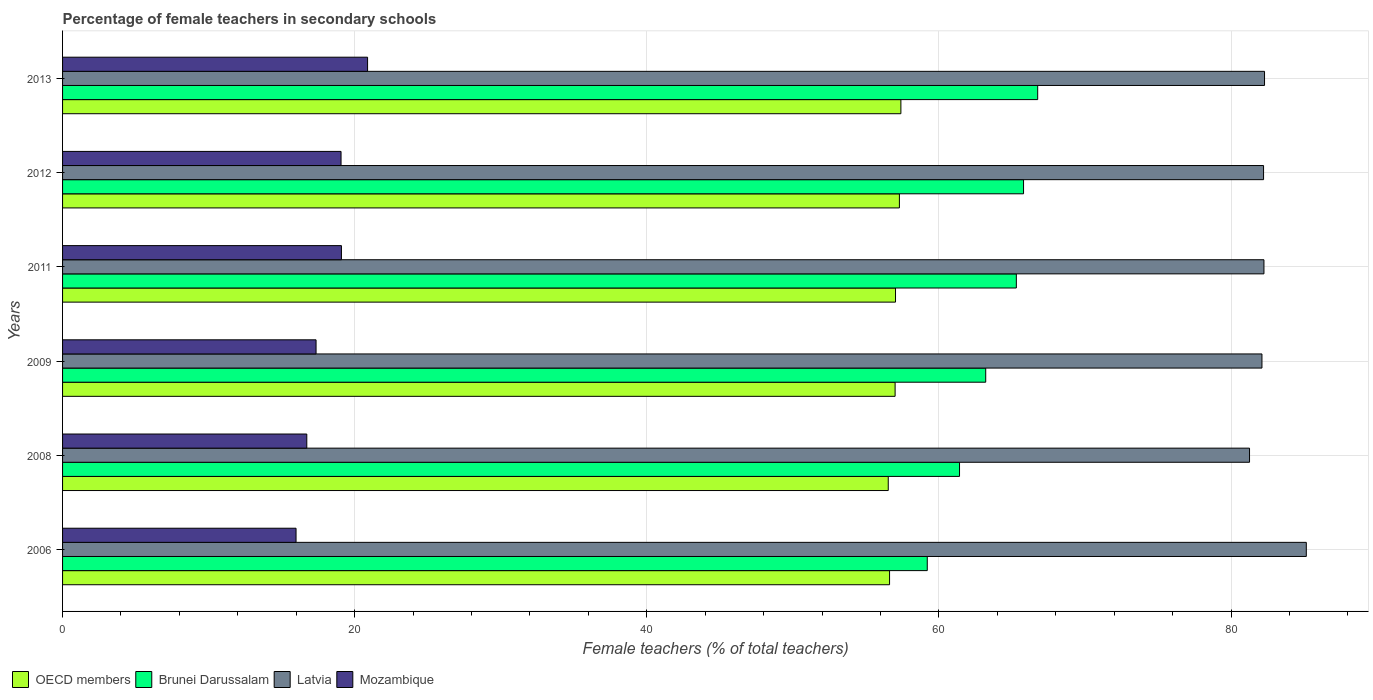How many groups of bars are there?
Provide a succinct answer. 6. Are the number of bars per tick equal to the number of legend labels?
Your response must be concise. Yes. How many bars are there on the 6th tick from the top?
Make the answer very short. 4. How many bars are there on the 2nd tick from the bottom?
Provide a succinct answer. 4. In how many cases, is the number of bars for a given year not equal to the number of legend labels?
Give a very brief answer. 0. What is the percentage of female teachers in Mozambique in 2009?
Ensure brevity in your answer.  17.36. Across all years, what is the maximum percentage of female teachers in Brunei Darussalam?
Make the answer very short. 66.76. Across all years, what is the minimum percentage of female teachers in OECD members?
Your answer should be very brief. 56.53. In which year was the percentage of female teachers in OECD members maximum?
Your answer should be compact. 2013. What is the total percentage of female teachers in Mozambique in the graph?
Ensure brevity in your answer.  109.1. What is the difference between the percentage of female teachers in Latvia in 2009 and that in 2013?
Offer a terse response. -0.18. What is the difference between the percentage of female teachers in Mozambique in 2013 and the percentage of female teachers in Latvia in 2012?
Your answer should be very brief. -61.34. What is the average percentage of female teachers in Mozambique per year?
Provide a short and direct response. 18.18. In the year 2012, what is the difference between the percentage of female teachers in Latvia and percentage of female teachers in OECD members?
Your answer should be very brief. 24.93. What is the ratio of the percentage of female teachers in OECD members in 2008 to that in 2011?
Your answer should be very brief. 0.99. Is the percentage of female teachers in Mozambique in 2011 less than that in 2013?
Your answer should be very brief. Yes. What is the difference between the highest and the second highest percentage of female teachers in Brunei Darussalam?
Offer a terse response. 0.97. What is the difference between the highest and the lowest percentage of female teachers in Mozambique?
Your response must be concise. 4.9. In how many years, is the percentage of female teachers in OECD members greater than the average percentage of female teachers in OECD members taken over all years?
Your response must be concise. 4. Is it the case that in every year, the sum of the percentage of female teachers in Latvia and percentage of female teachers in Brunei Darussalam is greater than the sum of percentage of female teachers in OECD members and percentage of female teachers in Mozambique?
Your response must be concise. Yes. What does the 3rd bar from the top in 2013 represents?
Your response must be concise. Brunei Darussalam. What does the 2nd bar from the bottom in 2006 represents?
Keep it short and to the point. Brunei Darussalam. Is it the case that in every year, the sum of the percentage of female teachers in Latvia and percentage of female teachers in OECD members is greater than the percentage of female teachers in Mozambique?
Provide a short and direct response. Yes. How many bars are there?
Provide a succinct answer. 24. Are all the bars in the graph horizontal?
Offer a very short reply. Yes. Does the graph contain any zero values?
Provide a short and direct response. No. How many legend labels are there?
Provide a succinct answer. 4. How are the legend labels stacked?
Make the answer very short. Horizontal. What is the title of the graph?
Your answer should be compact. Percentage of female teachers in secondary schools. Does "Mexico" appear as one of the legend labels in the graph?
Offer a very short reply. No. What is the label or title of the X-axis?
Keep it short and to the point. Female teachers (% of total teachers). What is the label or title of the Y-axis?
Ensure brevity in your answer.  Years. What is the Female teachers (% of total teachers) in OECD members in 2006?
Provide a succinct answer. 56.62. What is the Female teachers (% of total teachers) in Brunei Darussalam in 2006?
Your answer should be compact. 59.2. What is the Female teachers (% of total teachers) of Latvia in 2006?
Your answer should be very brief. 85.15. What is the Female teachers (% of total teachers) in Mozambique in 2006?
Make the answer very short. 15.99. What is the Female teachers (% of total teachers) in OECD members in 2008?
Give a very brief answer. 56.53. What is the Female teachers (% of total teachers) of Brunei Darussalam in 2008?
Offer a very short reply. 61.41. What is the Female teachers (% of total teachers) in Latvia in 2008?
Offer a very short reply. 81.27. What is the Female teachers (% of total teachers) of Mozambique in 2008?
Give a very brief answer. 16.72. What is the Female teachers (% of total teachers) in OECD members in 2009?
Your answer should be compact. 57. What is the Female teachers (% of total teachers) in Brunei Darussalam in 2009?
Make the answer very short. 63.2. What is the Female teachers (% of total teachers) in Latvia in 2009?
Provide a succinct answer. 82.12. What is the Female teachers (% of total teachers) in Mozambique in 2009?
Offer a terse response. 17.36. What is the Female teachers (% of total teachers) of OECD members in 2011?
Give a very brief answer. 57.03. What is the Female teachers (% of total teachers) in Brunei Darussalam in 2011?
Your answer should be very brief. 65.3. What is the Female teachers (% of total teachers) of Latvia in 2011?
Your answer should be compact. 82.25. What is the Female teachers (% of total teachers) in Mozambique in 2011?
Keep it short and to the point. 19.09. What is the Female teachers (% of total teachers) of OECD members in 2012?
Offer a very short reply. 57.29. What is the Female teachers (% of total teachers) of Brunei Darussalam in 2012?
Make the answer very short. 65.79. What is the Female teachers (% of total teachers) of Latvia in 2012?
Offer a terse response. 82.23. What is the Female teachers (% of total teachers) of Mozambique in 2012?
Offer a very short reply. 19.07. What is the Female teachers (% of total teachers) of OECD members in 2013?
Keep it short and to the point. 57.4. What is the Female teachers (% of total teachers) in Brunei Darussalam in 2013?
Provide a succinct answer. 66.76. What is the Female teachers (% of total teachers) of Latvia in 2013?
Provide a succinct answer. 82.29. What is the Female teachers (% of total teachers) of Mozambique in 2013?
Keep it short and to the point. 20.88. Across all years, what is the maximum Female teachers (% of total teachers) in OECD members?
Ensure brevity in your answer.  57.4. Across all years, what is the maximum Female teachers (% of total teachers) in Brunei Darussalam?
Your answer should be very brief. 66.76. Across all years, what is the maximum Female teachers (% of total teachers) in Latvia?
Provide a succinct answer. 85.15. Across all years, what is the maximum Female teachers (% of total teachers) in Mozambique?
Offer a terse response. 20.88. Across all years, what is the minimum Female teachers (% of total teachers) of OECD members?
Keep it short and to the point. 56.53. Across all years, what is the minimum Female teachers (% of total teachers) in Brunei Darussalam?
Your response must be concise. 59.2. Across all years, what is the minimum Female teachers (% of total teachers) in Latvia?
Your response must be concise. 81.27. Across all years, what is the minimum Female teachers (% of total teachers) in Mozambique?
Make the answer very short. 15.99. What is the total Female teachers (% of total teachers) in OECD members in the graph?
Offer a very short reply. 341.87. What is the total Female teachers (% of total teachers) of Brunei Darussalam in the graph?
Provide a succinct answer. 381.67. What is the total Female teachers (% of total teachers) of Latvia in the graph?
Your response must be concise. 495.3. What is the total Female teachers (% of total teachers) in Mozambique in the graph?
Ensure brevity in your answer.  109.1. What is the difference between the Female teachers (% of total teachers) of OECD members in 2006 and that in 2008?
Provide a succinct answer. 0.09. What is the difference between the Female teachers (% of total teachers) in Brunei Darussalam in 2006 and that in 2008?
Give a very brief answer. -2.21. What is the difference between the Female teachers (% of total teachers) in Latvia in 2006 and that in 2008?
Your answer should be very brief. 3.89. What is the difference between the Female teachers (% of total teachers) in Mozambique in 2006 and that in 2008?
Provide a succinct answer. -0.74. What is the difference between the Female teachers (% of total teachers) in OECD members in 2006 and that in 2009?
Give a very brief answer. -0.38. What is the difference between the Female teachers (% of total teachers) of Brunei Darussalam in 2006 and that in 2009?
Keep it short and to the point. -4. What is the difference between the Female teachers (% of total teachers) in Latvia in 2006 and that in 2009?
Offer a very short reply. 3.04. What is the difference between the Female teachers (% of total teachers) of Mozambique in 2006 and that in 2009?
Your answer should be very brief. -1.37. What is the difference between the Female teachers (% of total teachers) in OECD members in 2006 and that in 2011?
Your response must be concise. -0.41. What is the difference between the Female teachers (% of total teachers) of Brunei Darussalam in 2006 and that in 2011?
Provide a succinct answer. -6.1. What is the difference between the Female teachers (% of total teachers) in Latvia in 2006 and that in 2011?
Your response must be concise. 2.9. What is the difference between the Female teachers (% of total teachers) of Mozambique in 2006 and that in 2011?
Your answer should be very brief. -3.11. What is the difference between the Female teachers (% of total teachers) in OECD members in 2006 and that in 2012?
Your response must be concise. -0.67. What is the difference between the Female teachers (% of total teachers) of Brunei Darussalam in 2006 and that in 2012?
Your answer should be very brief. -6.59. What is the difference between the Female teachers (% of total teachers) of Latvia in 2006 and that in 2012?
Offer a terse response. 2.93. What is the difference between the Female teachers (% of total teachers) in Mozambique in 2006 and that in 2012?
Provide a short and direct response. -3.08. What is the difference between the Female teachers (% of total teachers) in OECD members in 2006 and that in 2013?
Your response must be concise. -0.78. What is the difference between the Female teachers (% of total teachers) of Brunei Darussalam in 2006 and that in 2013?
Offer a very short reply. -7.56. What is the difference between the Female teachers (% of total teachers) of Latvia in 2006 and that in 2013?
Provide a succinct answer. 2.86. What is the difference between the Female teachers (% of total teachers) of Mozambique in 2006 and that in 2013?
Ensure brevity in your answer.  -4.9. What is the difference between the Female teachers (% of total teachers) in OECD members in 2008 and that in 2009?
Your answer should be compact. -0.47. What is the difference between the Female teachers (% of total teachers) of Brunei Darussalam in 2008 and that in 2009?
Provide a short and direct response. -1.79. What is the difference between the Female teachers (% of total teachers) of Latvia in 2008 and that in 2009?
Provide a short and direct response. -0.85. What is the difference between the Female teachers (% of total teachers) in Mozambique in 2008 and that in 2009?
Your answer should be compact. -0.63. What is the difference between the Female teachers (% of total teachers) of OECD members in 2008 and that in 2011?
Your response must be concise. -0.5. What is the difference between the Female teachers (% of total teachers) of Brunei Darussalam in 2008 and that in 2011?
Offer a terse response. -3.89. What is the difference between the Female teachers (% of total teachers) of Latvia in 2008 and that in 2011?
Provide a succinct answer. -0.99. What is the difference between the Female teachers (% of total teachers) of Mozambique in 2008 and that in 2011?
Offer a terse response. -2.37. What is the difference between the Female teachers (% of total teachers) in OECD members in 2008 and that in 2012?
Provide a succinct answer. -0.76. What is the difference between the Female teachers (% of total teachers) of Brunei Darussalam in 2008 and that in 2012?
Your response must be concise. -4.38. What is the difference between the Female teachers (% of total teachers) of Latvia in 2008 and that in 2012?
Your answer should be compact. -0.96. What is the difference between the Female teachers (% of total teachers) of Mozambique in 2008 and that in 2012?
Ensure brevity in your answer.  -2.34. What is the difference between the Female teachers (% of total teachers) of OECD members in 2008 and that in 2013?
Your response must be concise. -0.87. What is the difference between the Female teachers (% of total teachers) in Brunei Darussalam in 2008 and that in 2013?
Your response must be concise. -5.35. What is the difference between the Female teachers (% of total teachers) of Latvia in 2008 and that in 2013?
Offer a terse response. -1.03. What is the difference between the Female teachers (% of total teachers) of Mozambique in 2008 and that in 2013?
Your answer should be compact. -4.16. What is the difference between the Female teachers (% of total teachers) of OECD members in 2009 and that in 2011?
Offer a very short reply. -0.03. What is the difference between the Female teachers (% of total teachers) in Brunei Darussalam in 2009 and that in 2011?
Keep it short and to the point. -2.1. What is the difference between the Female teachers (% of total teachers) in Latvia in 2009 and that in 2011?
Ensure brevity in your answer.  -0.14. What is the difference between the Female teachers (% of total teachers) of Mozambique in 2009 and that in 2011?
Provide a short and direct response. -1.74. What is the difference between the Female teachers (% of total teachers) in OECD members in 2009 and that in 2012?
Your answer should be very brief. -0.29. What is the difference between the Female teachers (% of total teachers) in Brunei Darussalam in 2009 and that in 2012?
Provide a succinct answer. -2.59. What is the difference between the Female teachers (% of total teachers) of Latvia in 2009 and that in 2012?
Provide a short and direct response. -0.11. What is the difference between the Female teachers (% of total teachers) in Mozambique in 2009 and that in 2012?
Give a very brief answer. -1.71. What is the difference between the Female teachers (% of total teachers) of OECD members in 2009 and that in 2013?
Provide a short and direct response. -0.4. What is the difference between the Female teachers (% of total teachers) in Brunei Darussalam in 2009 and that in 2013?
Provide a succinct answer. -3.56. What is the difference between the Female teachers (% of total teachers) of Latvia in 2009 and that in 2013?
Your answer should be very brief. -0.18. What is the difference between the Female teachers (% of total teachers) in Mozambique in 2009 and that in 2013?
Provide a succinct answer. -3.53. What is the difference between the Female teachers (% of total teachers) in OECD members in 2011 and that in 2012?
Provide a succinct answer. -0.27. What is the difference between the Female teachers (% of total teachers) of Brunei Darussalam in 2011 and that in 2012?
Offer a terse response. -0.49. What is the difference between the Female teachers (% of total teachers) in Latvia in 2011 and that in 2012?
Your answer should be compact. 0.03. What is the difference between the Female teachers (% of total teachers) of Mozambique in 2011 and that in 2012?
Provide a succinct answer. 0.03. What is the difference between the Female teachers (% of total teachers) in OECD members in 2011 and that in 2013?
Make the answer very short. -0.37. What is the difference between the Female teachers (% of total teachers) in Brunei Darussalam in 2011 and that in 2013?
Make the answer very short. -1.46. What is the difference between the Female teachers (% of total teachers) of Latvia in 2011 and that in 2013?
Offer a very short reply. -0.04. What is the difference between the Female teachers (% of total teachers) of Mozambique in 2011 and that in 2013?
Give a very brief answer. -1.79. What is the difference between the Female teachers (% of total teachers) in OECD members in 2012 and that in 2013?
Offer a terse response. -0.1. What is the difference between the Female teachers (% of total teachers) of Brunei Darussalam in 2012 and that in 2013?
Keep it short and to the point. -0.97. What is the difference between the Female teachers (% of total teachers) in Latvia in 2012 and that in 2013?
Keep it short and to the point. -0.07. What is the difference between the Female teachers (% of total teachers) in Mozambique in 2012 and that in 2013?
Provide a succinct answer. -1.82. What is the difference between the Female teachers (% of total teachers) of OECD members in 2006 and the Female teachers (% of total teachers) of Brunei Darussalam in 2008?
Offer a terse response. -4.79. What is the difference between the Female teachers (% of total teachers) of OECD members in 2006 and the Female teachers (% of total teachers) of Latvia in 2008?
Your answer should be compact. -24.65. What is the difference between the Female teachers (% of total teachers) of OECD members in 2006 and the Female teachers (% of total teachers) of Mozambique in 2008?
Keep it short and to the point. 39.9. What is the difference between the Female teachers (% of total teachers) of Brunei Darussalam in 2006 and the Female teachers (% of total teachers) of Latvia in 2008?
Keep it short and to the point. -22.06. What is the difference between the Female teachers (% of total teachers) in Brunei Darussalam in 2006 and the Female teachers (% of total teachers) in Mozambique in 2008?
Provide a succinct answer. 42.48. What is the difference between the Female teachers (% of total teachers) in Latvia in 2006 and the Female teachers (% of total teachers) in Mozambique in 2008?
Ensure brevity in your answer.  68.43. What is the difference between the Female teachers (% of total teachers) in OECD members in 2006 and the Female teachers (% of total teachers) in Brunei Darussalam in 2009?
Your response must be concise. -6.58. What is the difference between the Female teachers (% of total teachers) of OECD members in 2006 and the Female teachers (% of total teachers) of Latvia in 2009?
Provide a succinct answer. -25.5. What is the difference between the Female teachers (% of total teachers) of OECD members in 2006 and the Female teachers (% of total teachers) of Mozambique in 2009?
Offer a very short reply. 39.26. What is the difference between the Female teachers (% of total teachers) in Brunei Darussalam in 2006 and the Female teachers (% of total teachers) in Latvia in 2009?
Your answer should be very brief. -22.91. What is the difference between the Female teachers (% of total teachers) in Brunei Darussalam in 2006 and the Female teachers (% of total teachers) in Mozambique in 2009?
Provide a succinct answer. 41.85. What is the difference between the Female teachers (% of total teachers) of Latvia in 2006 and the Female teachers (% of total teachers) of Mozambique in 2009?
Offer a very short reply. 67.8. What is the difference between the Female teachers (% of total teachers) of OECD members in 2006 and the Female teachers (% of total teachers) of Brunei Darussalam in 2011?
Provide a short and direct response. -8.68. What is the difference between the Female teachers (% of total teachers) in OECD members in 2006 and the Female teachers (% of total teachers) in Latvia in 2011?
Provide a short and direct response. -25.63. What is the difference between the Female teachers (% of total teachers) of OECD members in 2006 and the Female teachers (% of total teachers) of Mozambique in 2011?
Provide a short and direct response. 37.53. What is the difference between the Female teachers (% of total teachers) in Brunei Darussalam in 2006 and the Female teachers (% of total teachers) in Latvia in 2011?
Offer a very short reply. -23.05. What is the difference between the Female teachers (% of total teachers) in Brunei Darussalam in 2006 and the Female teachers (% of total teachers) in Mozambique in 2011?
Your answer should be compact. 40.11. What is the difference between the Female teachers (% of total teachers) of Latvia in 2006 and the Female teachers (% of total teachers) of Mozambique in 2011?
Make the answer very short. 66.06. What is the difference between the Female teachers (% of total teachers) in OECD members in 2006 and the Female teachers (% of total teachers) in Brunei Darussalam in 2012?
Provide a short and direct response. -9.17. What is the difference between the Female teachers (% of total teachers) of OECD members in 2006 and the Female teachers (% of total teachers) of Latvia in 2012?
Give a very brief answer. -25.61. What is the difference between the Female teachers (% of total teachers) in OECD members in 2006 and the Female teachers (% of total teachers) in Mozambique in 2012?
Your response must be concise. 37.55. What is the difference between the Female teachers (% of total teachers) in Brunei Darussalam in 2006 and the Female teachers (% of total teachers) in Latvia in 2012?
Provide a succinct answer. -23.02. What is the difference between the Female teachers (% of total teachers) in Brunei Darussalam in 2006 and the Female teachers (% of total teachers) in Mozambique in 2012?
Offer a very short reply. 40.14. What is the difference between the Female teachers (% of total teachers) in Latvia in 2006 and the Female teachers (% of total teachers) in Mozambique in 2012?
Provide a short and direct response. 66.09. What is the difference between the Female teachers (% of total teachers) in OECD members in 2006 and the Female teachers (% of total teachers) in Brunei Darussalam in 2013?
Provide a short and direct response. -10.14. What is the difference between the Female teachers (% of total teachers) in OECD members in 2006 and the Female teachers (% of total teachers) in Latvia in 2013?
Provide a short and direct response. -25.67. What is the difference between the Female teachers (% of total teachers) in OECD members in 2006 and the Female teachers (% of total teachers) in Mozambique in 2013?
Offer a terse response. 35.74. What is the difference between the Female teachers (% of total teachers) in Brunei Darussalam in 2006 and the Female teachers (% of total teachers) in Latvia in 2013?
Ensure brevity in your answer.  -23.09. What is the difference between the Female teachers (% of total teachers) in Brunei Darussalam in 2006 and the Female teachers (% of total teachers) in Mozambique in 2013?
Your response must be concise. 38.32. What is the difference between the Female teachers (% of total teachers) of Latvia in 2006 and the Female teachers (% of total teachers) of Mozambique in 2013?
Your answer should be very brief. 64.27. What is the difference between the Female teachers (% of total teachers) in OECD members in 2008 and the Female teachers (% of total teachers) in Brunei Darussalam in 2009?
Offer a terse response. -6.67. What is the difference between the Female teachers (% of total teachers) in OECD members in 2008 and the Female teachers (% of total teachers) in Latvia in 2009?
Offer a terse response. -25.59. What is the difference between the Female teachers (% of total teachers) of OECD members in 2008 and the Female teachers (% of total teachers) of Mozambique in 2009?
Offer a terse response. 39.18. What is the difference between the Female teachers (% of total teachers) in Brunei Darussalam in 2008 and the Female teachers (% of total teachers) in Latvia in 2009?
Give a very brief answer. -20.71. What is the difference between the Female teachers (% of total teachers) of Brunei Darussalam in 2008 and the Female teachers (% of total teachers) of Mozambique in 2009?
Your response must be concise. 44.06. What is the difference between the Female teachers (% of total teachers) of Latvia in 2008 and the Female teachers (% of total teachers) of Mozambique in 2009?
Ensure brevity in your answer.  63.91. What is the difference between the Female teachers (% of total teachers) of OECD members in 2008 and the Female teachers (% of total teachers) of Brunei Darussalam in 2011?
Ensure brevity in your answer.  -8.77. What is the difference between the Female teachers (% of total teachers) in OECD members in 2008 and the Female teachers (% of total teachers) in Latvia in 2011?
Your answer should be compact. -25.72. What is the difference between the Female teachers (% of total teachers) in OECD members in 2008 and the Female teachers (% of total teachers) in Mozambique in 2011?
Offer a terse response. 37.44. What is the difference between the Female teachers (% of total teachers) of Brunei Darussalam in 2008 and the Female teachers (% of total teachers) of Latvia in 2011?
Make the answer very short. -20.84. What is the difference between the Female teachers (% of total teachers) in Brunei Darussalam in 2008 and the Female teachers (% of total teachers) in Mozambique in 2011?
Your response must be concise. 42.32. What is the difference between the Female teachers (% of total teachers) in Latvia in 2008 and the Female teachers (% of total teachers) in Mozambique in 2011?
Provide a short and direct response. 62.17. What is the difference between the Female teachers (% of total teachers) of OECD members in 2008 and the Female teachers (% of total teachers) of Brunei Darussalam in 2012?
Provide a succinct answer. -9.26. What is the difference between the Female teachers (% of total teachers) of OECD members in 2008 and the Female teachers (% of total teachers) of Latvia in 2012?
Provide a succinct answer. -25.7. What is the difference between the Female teachers (% of total teachers) of OECD members in 2008 and the Female teachers (% of total teachers) of Mozambique in 2012?
Provide a succinct answer. 37.46. What is the difference between the Female teachers (% of total teachers) in Brunei Darussalam in 2008 and the Female teachers (% of total teachers) in Latvia in 2012?
Make the answer very short. -20.82. What is the difference between the Female teachers (% of total teachers) of Brunei Darussalam in 2008 and the Female teachers (% of total teachers) of Mozambique in 2012?
Provide a short and direct response. 42.34. What is the difference between the Female teachers (% of total teachers) in Latvia in 2008 and the Female teachers (% of total teachers) in Mozambique in 2012?
Provide a short and direct response. 62.2. What is the difference between the Female teachers (% of total teachers) of OECD members in 2008 and the Female teachers (% of total teachers) of Brunei Darussalam in 2013?
Keep it short and to the point. -10.23. What is the difference between the Female teachers (% of total teachers) of OECD members in 2008 and the Female teachers (% of total teachers) of Latvia in 2013?
Your answer should be compact. -25.76. What is the difference between the Female teachers (% of total teachers) of OECD members in 2008 and the Female teachers (% of total teachers) of Mozambique in 2013?
Provide a succinct answer. 35.65. What is the difference between the Female teachers (% of total teachers) of Brunei Darussalam in 2008 and the Female teachers (% of total teachers) of Latvia in 2013?
Your answer should be very brief. -20.88. What is the difference between the Female teachers (% of total teachers) in Brunei Darussalam in 2008 and the Female teachers (% of total teachers) in Mozambique in 2013?
Offer a very short reply. 40.53. What is the difference between the Female teachers (% of total teachers) of Latvia in 2008 and the Female teachers (% of total teachers) of Mozambique in 2013?
Provide a succinct answer. 60.38. What is the difference between the Female teachers (% of total teachers) of OECD members in 2009 and the Female teachers (% of total teachers) of Brunei Darussalam in 2011?
Your answer should be very brief. -8.3. What is the difference between the Female teachers (% of total teachers) of OECD members in 2009 and the Female teachers (% of total teachers) of Latvia in 2011?
Provide a succinct answer. -25.25. What is the difference between the Female teachers (% of total teachers) in OECD members in 2009 and the Female teachers (% of total teachers) in Mozambique in 2011?
Your answer should be very brief. 37.91. What is the difference between the Female teachers (% of total teachers) of Brunei Darussalam in 2009 and the Female teachers (% of total teachers) of Latvia in 2011?
Keep it short and to the point. -19.05. What is the difference between the Female teachers (% of total teachers) of Brunei Darussalam in 2009 and the Female teachers (% of total teachers) of Mozambique in 2011?
Provide a short and direct response. 44.11. What is the difference between the Female teachers (% of total teachers) in Latvia in 2009 and the Female teachers (% of total teachers) in Mozambique in 2011?
Your answer should be very brief. 63.02. What is the difference between the Female teachers (% of total teachers) of OECD members in 2009 and the Female teachers (% of total teachers) of Brunei Darussalam in 2012?
Your answer should be compact. -8.79. What is the difference between the Female teachers (% of total teachers) in OECD members in 2009 and the Female teachers (% of total teachers) in Latvia in 2012?
Provide a succinct answer. -25.23. What is the difference between the Female teachers (% of total teachers) in OECD members in 2009 and the Female teachers (% of total teachers) in Mozambique in 2012?
Provide a succinct answer. 37.93. What is the difference between the Female teachers (% of total teachers) of Brunei Darussalam in 2009 and the Female teachers (% of total teachers) of Latvia in 2012?
Provide a short and direct response. -19.02. What is the difference between the Female teachers (% of total teachers) in Brunei Darussalam in 2009 and the Female teachers (% of total teachers) in Mozambique in 2012?
Offer a terse response. 44.14. What is the difference between the Female teachers (% of total teachers) in Latvia in 2009 and the Female teachers (% of total teachers) in Mozambique in 2012?
Your response must be concise. 63.05. What is the difference between the Female teachers (% of total teachers) in OECD members in 2009 and the Female teachers (% of total teachers) in Brunei Darussalam in 2013?
Ensure brevity in your answer.  -9.76. What is the difference between the Female teachers (% of total teachers) of OECD members in 2009 and the Female teachers (% of total teachers) of Latvia in 2013?
Provide a succinct answer. -25.29. What is the difference between the Female teachers (% of total teachers) of OECD members in 2009 and the Female teachers (% of total teachers) of Mozambique in 2013?
Offer a terse response. 36.12. What is the difference between the Female teachers (% of total teachers) of Brunei Darussalam in 2009 and the Female teachers (% of total teachers) of Latvia in 2013?
Offer a very short reply. -19.09. What is the difference between the Female teachers (% of total teachers) in Brunei Darussalam in 2009 and the Female teachers (% of total teachers) in Mozambique in 2013?
Provide a short and direct response. 42.32. What is the difference between the Female teachers (% of total teachers) of Latvia in 2009 and the Female teachers (% of total teachers) of Mozambique in 2013?
Ensure brevity in your answer.  61.23. What is the difference between the Female teachers (% of total teachers) of OECD members in 2011 and the Female teachers (% of total teachers) of Brunei Darussalam in 2012?
Provide a succinct answer. -8.77. What is the difference between the Female teachers (% of total teachers) in OECD members in 2011 and the Female teachers (% of total teachers) in Latvia in 2012?
Offer a terse response. -25.2. What is the difference between the Female teachers (% of total teachers) of OECD members in 2011 and the Female teachers (% of total teachers) of Mozambique in 2012?
Your response must be concise. 37.96. What is the difference between the Female teachers (% of total teachers) of Brunei Darussalam in 2011 and the Female teachers (% of total teachers) of Latvia in 2012?
Provide a short and direct response. -16.93. What is the difference between the Female teachers (% of total teachers) in Brunei Darussalam in 2011 and the Female teachers (% of total teachers) in Mozambique in 2012?
Make the answer very short. 46.23. What is the difference between the Female teachers (% of total teachers) in Latvia in 2011 and the Female teachers (% of total teachers) in Mozambique in 2012?
Offer a terse response. 63.19. What is the difference between the Female teachers (% of total teachers) in OECD members in 2011 and the Female teachers (% of total teachers) in Brunei Darussalam in 2013?
Make the answer very short. -9.73. What is the difference between the Female teachers (% of total teachers) of OECD members in 2011 and the Female teachers (% of total teachers) of Latvia in 2013?
Ensure brevity in your answer.  -25.26. What is the difference between the Female teachers (% of total teachers) in OECD members in 2011 and the Female teachers (% of total teachers) in Mozambique in 2013?
Ensure brevity in your answer.  36.15. What is the difference between the Female teachers (% of total teachers) of Brunei Darussalam in 2011 and the Female teachers (% of total teachers) of Latvia in 2013?
Keep it short and to the point. -16.99. What is the difference between the Female teachers (% of total teachers) in Brunei Darussalam in 2011 and the Female teachers (% of total teachers) in Mozambique in 2013?
Offer a terse response. 44.42. What is the difference between the Female teachers (% of total teachers) in Latvia in 2011 and the Female teachers (% of total teachers) in Mozambique in 2013?
Make the answer very short. 61.37. What is the difference between the Female teachers (% of total teachers) of OECD members in 2012 and the Female teachers (% of total teachers) of Brunei Darussalam in 2013?
Ensure brevity in your answer.  -9.47. What is the difference between the Female teachers (% of total teachers) in OECD members in 2012 and the Female teachers (% of total teachers) in Latvia in 2013?
Offer a terse response. -25. What is the difference between the Female teachers (% of total teachers) of OECD members in 2012 and the Female teachers (% of total teachers) of Mozambique in 2013?
Your answer should be very brief. 36.41. What is the difference between the Female teachers (% of total teachers) in Brunei Darussalam in 2012 and the Female teachers (% of total teachers) in Latvia in 2013?
Offer a terse response. -16.5. What is the difference between the Female teachers (% of total teachers) of Brunei Darussalam in 2012 and the Female teachers (% of total teachers) of Mozambique in 2013?
Provide a succinct answer. 44.91. What is the difference between the Female teachers (% of total teachers) in Latvia in 2012 and the Female teachers (% of total teachers) in Mozambique in 2013?
Your response must be concise. 61.34. What is the average Female teachers (% of total teachers) in OECD members per year?
Your answer should be very brief. 56.98. What is the average Female teachers (% of total teachers) of Brunei Darussalam per year?
Offer a terse response. 63.61. What is the average Female teachers (% of total teachers) of Latvia per year?
Provide a succinct answer. 82.55. What is the average Female teachers (% of total teachers) in Mozambique per year?
Give a very brief answer. 18.18. In the year 2006, what is the difference between the Female teachers (% of total teachers) of OECD members and Female teachers (% of total teachers) of Brunei Darussalam?
Ensure brevity in your answer.  -2.58. In the year 2006, what is the difference between the Female teachers (% of total teachers) in OECD members and Female teachers (% of total teachers) in Latvia?
Make the answer very short. -28.53. In the year 2006, what is the difference between the Female teachers (% of total teachers) in OECD members and Female teachers (% of total teachers) in Mozambique?
Keep it short and to the point. 40.63. In the year 2006, what is the difference between the Female teachers (% of total teachers) in Brunei Darussalam and Female teachers (% of total teachers) in Latvia?
Your response must be concise. -25.95. In the year 2006, what is the difference between the Female teachers (% of total teachers) of Brunei Darussalam and Female teachers (% of total teachers) of Mozambique?
Offer a terse response. 43.22. In the year 2006, what is the difference between the Female teachers (% of total teachers) of Latvia and Female teachers (% of total teachers) of Mozambique?
Provide a short and direct response. 69.17. In the year 2008, what is the difference between the Female teachers (% of total teachers) of OECD members and Female teachers (% of total teachers) of Brunei Darussalam?
Your answer should be compact. -4.88. In the year 2008, what is the difference between the Female teachers (% of total teachers) in OECD members and Female teachers (% of total teachers) in Latvia?
Offer a terse response. -24.74. In the year 2008, what is the difference between the Female teachers (% of total teachers) in OECD members and Female teachers (% of total teachers) in Mozambique?
Your response must be concise. 39.81. In the year 2008, what is the difference between the Female teachers (% of total teachers) in Brunei Darussalam and Female teachers (% of total teachers) in Latvia?
Your response must be concise. -19.85. In the year 2008, what is the difference between the Female teachers (% of total teachers) of Brunei Darussalam and Female teachers (% of total teachers) of Mozambique?
Your answer should be compact. 44.69. In the year 2008, what is the difference between the Female teachers (% of total teachers) in Latvia and Female teachers (% of total teachers) in Mozambique?
Your answer should be compact. 64.54. In the year 2009, what is the difference between the Female teachers (% of total teachers) in OECD members and Female teachers (% of total teachers) in Brunei Darussalam?
Ensure brevity in your answer.  -6.2. In the year 2009, what is the difference between the Female teachers (% of total teachers) in OECD members and Female teachers (% of total teachers) in Latvia?
Give a very brief answer. -25.12. In the year 2009, what is the difference between the Female teachers (% of total teachers) of OECD members and Female teachers (% of total teachers) of Mozambique?
Provide a succinct answer. 39.65. In the year 2009, what is the difference between the Female teachers (% of total teachers) in Brunei Darussalam and Female teachers (% of total teachers) in Latvia?
Give a very brief answer. -18.91. In the year 2009, what is the difference between the Female teachers (% of total teachers) of Brunei Darussalam and Female teachers (% of total teachers) of Mozambique?
Your answer should be compact. 45.85. In the year 2009, what is the difference between the Female teachers (% of total teachers) in Latvia and Female teachers (% of total teachers) in Mozambique?
Provide a short and direct response. 64.76. In the year 2011, what is the difference between the Female teachers (% of total teachers) in OECD members and Female teachers (% of total teachers) in Brunei Darussalam?
Your answer should be very brief. -8.27. In the year 2011, what is the difference between the Female teachers (% of total teachers) of OECD members and Female teachers (% of total teachers) of Latvia?
Your answer should be compact. -25.23. In the year 2011, what is the difference between the Female teachers (% of total teachers) of OECD members and Female teachers (% of total teachers) of Mozambique?
Your answer should be very brief. 37.94. In the year 2011, what is the difference between the Female teachers (% of total teachers) in Brunei Darussalam and Female teachers (% of total teachers) in Latvia?
Provide a short and direct response. -16.95. In the year 2011, what is the difference between the Female teachers (% of total teachers) of Brunei Darussalam and Female teachers (% of total teachers) of Mozambique?
Your response must be concise. 46.21. In the year 2011, what is the difference between the Female teachers (% of total teachers) in Latvia and Female teachers (% of total teachers) in Mozambique?
Keep it short and to the point. 63.16. In the year 2012, what is the difference between the Female teachers (% of total teachers) of OECD members and Female teachers (% of total teachers) of Brunei Darussalam?
Make the answer very short. -8.5. In the year 2012, what is the difference between the Female teachers (% of total teachers) of OECD members and Female teachers (% of total teachers) of Latvia?
Your response must be concise. -24.93. In the year 2012, what is the difference between the Female teachers (% of total teachers) in OECD members and Female teachers (% of total teachers) in Mozambique?
Provide a succinct answer. 38.23. In the year 2012, what is the difference between the Female teachers (% of total teachers) of Brunei Darussalam and Female teachers (% of total teachers) of Latvia?
Offer a terse response. -16.43. In the year 2012, what is the difference between the Female teachers (% of total teachers) of Brunei Darussalam and Female teachers (% of total teachers) of Mozambique?
Provide a short and direct response. 46.73. In the year 2012, what is the difference between the Female teachers (% of total teachers) in Latvia and Female teachers (% of total teachers) in Mozambique?
Ensure brevity in your answer.  63.16. In the year 2013, what is the difference between the Female teachers (% of total teachers) of OECD members and Female teachers (% of total teachers) of Brunei Darussalam?
Your answer should be compact. -9.37. In the year 2013, what is the difference between the Female teachers (% of total teachers) of OECD members and Female teachers (% of total teachers) of Latvia?
Give a very brief answer. -24.9. In the year 2013, what is the difference between the Female teachers (% of total teachers) in OECD members and Female teachers (% of total teachers) in Mozambique?
Offer a very short reply. 36.51. In the year 2013, what is the difference between the Female teachers (% of total teachers) of Brunei Darussalam and Female teachers (% of total teachers) of Latvia?
Provide a short and direct response. -15.53. In the year 2013, what is the difference between the Female teachers (% of total teachers) of Brunei Darussalam and Female teachers (% of total teachers) of Mozambique?
Offer a very short reply. 45.88. In the year 2013, what is the difference between the Female teachers (% of total teachers) in Latvia and Female teachers (% of total teachers) in Mozambique?
Provide a succinct answer. 61.41. What is the ratio of the Female teachers (% of total teachers) in OECD members in 2006 to that in 2008?
Give a very brief answer. 1. What is the ratio of the Female teachers (% of total teachers) of Latvia in 2006 to that in 2008?
Offer a terse response. 1.05. What is the ratio of the Female teachers (% of total teachers) in Mozambique in 2006 to that in 2008?
Ensure brevity in your answer.  0.96. What is the ratio of the Female teachers (% of total teachers) of OECD members in 2006 to that in 2009?
Give a very brief answer. 0.99. What is the ratio of the Female teachers (% of total teachers) in Brunei Darussalam in 2006 to that in 2009?
Your response must be concise. 0.94. What is the ratio of the Female teachers (% of total teachers) of Mozambique in 2006 to that in 2009?
Make the answer very short. 0.92. What is the ratio of the Female teachers (% of total teachers) of Brunei Darussalam in 2006 to that in 2011?
Give a very brief answer. 0.91. What is the ratio of the Female teachers (% of total teachers) of Latvia in 2006 to that in 2011?
Provide a short and direct response. 1.04. What is the ratio of the Female teachers (% of total teachers) of Mozambique in 2006 to that in 2011?
Offer a very short reply. 0.84. What is the ratio of the Female teachers (% of total teachers) of Brunei Darussalam in 2006 to that in 2012?
Your answer should be very brief. 0.9. What is the ratio of the Female teachers (% of total teachers) in Latvia in 2006 to that in 2012?
Ensure brevity in your answer.  1.04. What is the ratio of the Female teachers (% of total teachers) of Mozambique in 2006 to that in 2012?
Make the answer very short. 0.84. What is the ratio of the Female teachers (% of total teachers) in OECD members in 2006 to that in 2013?
Give a very brief answer. 0.99. What is the ratio of the Female teachers (% of total teachers) in Brunei Darussalam in 2006 to that in 2013?
Ensure brevity in your answer.  0.89. What is the ratio of the Female teachers (% of total teachers) in Latvia in 2006 to that in 2013?
Provide a succinct answer. 1.03. What is the ratio of the Female teachers (% of total teachers) in Mozambique in 2006 to that in 2013?
Offer a terse response. 0.77. What is the ratio of the Female teachers (% of total teachers) of Brunei Darussalam in 2008 to that in 2009?
Offer a very short reply. 0.97. What is the ratio of the Female teachers (% of total teachers) of Latvia in 2008 to that in 2009?
Offer a terse response. 0.99. What is the ratio of the Female teachers (% of total teachers) of Mozambique in 2008 to that in 2009?
Give a very brief answer. 0.96. What is the ratio of the Female teachers (% of total teachers) of OECD members in 2008 to that in 2011?
Offer a very short reply. 0.99. What is the ratio of the Female teachers (% of total teachers) in Brunei Darussalam in 2008 to that in 2011?
Provide a short and direct response. 0.94. What is the ratio of the Female teachers (% of total teachers) of Mozambique in 2008 to that in 2011?
Keep it short and to the point. 0.88. What is the ratio of the Female teachers (% of total teachers) in OECD members in 2008 to that in 2012?
Keep it short and to the point. 0.99. What is the ratio of the Female teachers (% of total teachers) in Brunei Darussalam in 2008 to that in 2012?
Provide a succinct answer. 0.93. What is the ratio of the Female teachers (% of total teachers) of Latvia in 2008 to that in 2012?
Your answer should be very brief. 0.99. What is the ratio of the Female teachers (% of total teachers) in Mozambique in 2008 to that in 2012?
Your answer should be compact. 0.88. What is the ratio of the Female teachers (% of total teachers) in OECD members in 2008 to that in 2013?
Your answer should be compact. 0.98. What is the ratio of the Female teachers (% of total teachers) of Brunei Darussalam in 2008 to that in 2013?
Offer a terse response. 0.92. What is the ratio of the Female teachers (% of total teachers) in Latvia in 2008 to that in 2013?
Provide a succinct answer. 0.99. What is the ratio of the Female teachers (% of total teachers) in Mozambique in 2008 to that in 2013?
Your answer should be compact. 0.8. What is the ratio of the Female teachers (% of total teachers) of Brunei Darussalam in 2009 to that in 2011?
Provide a succinct answer. 0.97. What is the ratio of the Female teachers (% of total teachers) of Mozambique in 2009 to that in 2011?
Your answer should be compact. 0.91. What is the ratio of the Female teachers (% of total teachers) of OECD members in 2009 to that in 2012?
Offer a terse response. 0.99. What is the ratio of the Female teachers (% of total teachers) of Brunei Darussalam in 2009 to that in 2012?
Make the answer very short. 0.96. What is the ratio of the Female teachers (% of total teachers) in Latvia in 2009 to that in 2012?
Ensure brevity in your answer.  1. What is the ratio of the Female teachers (% of total teachers) in Mozambique in 2009 to that in 2012?
Offer a very short reply. 0.91. What is the ratio of the Female teachers (% of total teachers) of OECD members in 2009 to that in 2013?
Offer a terse response. 0.99. What is the ratio of the Female teachers (% of total teachers) of Brunei Darussalam in 2009 to that in 2013?
Keep it short and to the point. 0.95. What is the ratio of the Female teachers (% of total teachers) in Mozambique in 2009 to that in 2013?
Keep it short and to the point. 0.83. What is the ratio of the Female teachers (% of total teachers) in OECD members in 2011 to that in 2012?
Offer a very short reply. 1. What is the ratio of the Female teachers (% of total teachers) in Mozambique in 2011 to that in 2012?
Provide a succinct answer. 1. What is the ratio of the Female teachers (% of total teachers) of OECD members in 2011 to that in 2013?
Give a very brief answer. 0.99. What is the ratio of the Female teachers (% of total teachers) in Brunei Darussalam in 2011 to that in 2013?
Your response must be concise. 0.98. What is the ratio of the Female teachers (% of total teachers) of Mozambique in 2011 to that in 2013?
Your answer should be compact. 0.91. What is the ratio of the Female teachers (% of total teachers) of Brunei Darussalam in 2012 to that in 2013?
Your answer should be very brief. 0.99. What is the difference between the highest and the second highest Female teachers (% of total teachers) in OECD members?
Offer a terse response. 0.1. What is the difference between the highest and the second highest Female teachers (% of total teachers) of Brunei Darussalam?
Your response must be concise. 0.97. What is the difference between the highest and the second highest Female teachers (% of total teachers) in Latvia?
Keep it short and to the point. 2.86. What is the difference between the highest and the second highest Female teachers (% of total teachers) of Mozambique?
Ensure brevity in your answer.  1.79. What is the difference between the highest and the lowest Female teachers (% of total teachers) of OECD members?
Make the answer very short. 0.87. What is the difference between the highest and the lowest Female teachers (% of total teachers) of Brunei Darussalam?
Provide a short and direct response. 7.56. What is the difference between the highest and the lowest Female teachers (% of total teachers) of Latvia?
Provide a short and direct response. 3.89. What is the difference between the highest and the lowest Female teachers (% of total teachers) in Mozambique?
Keep it short and to the point. 4.9. 